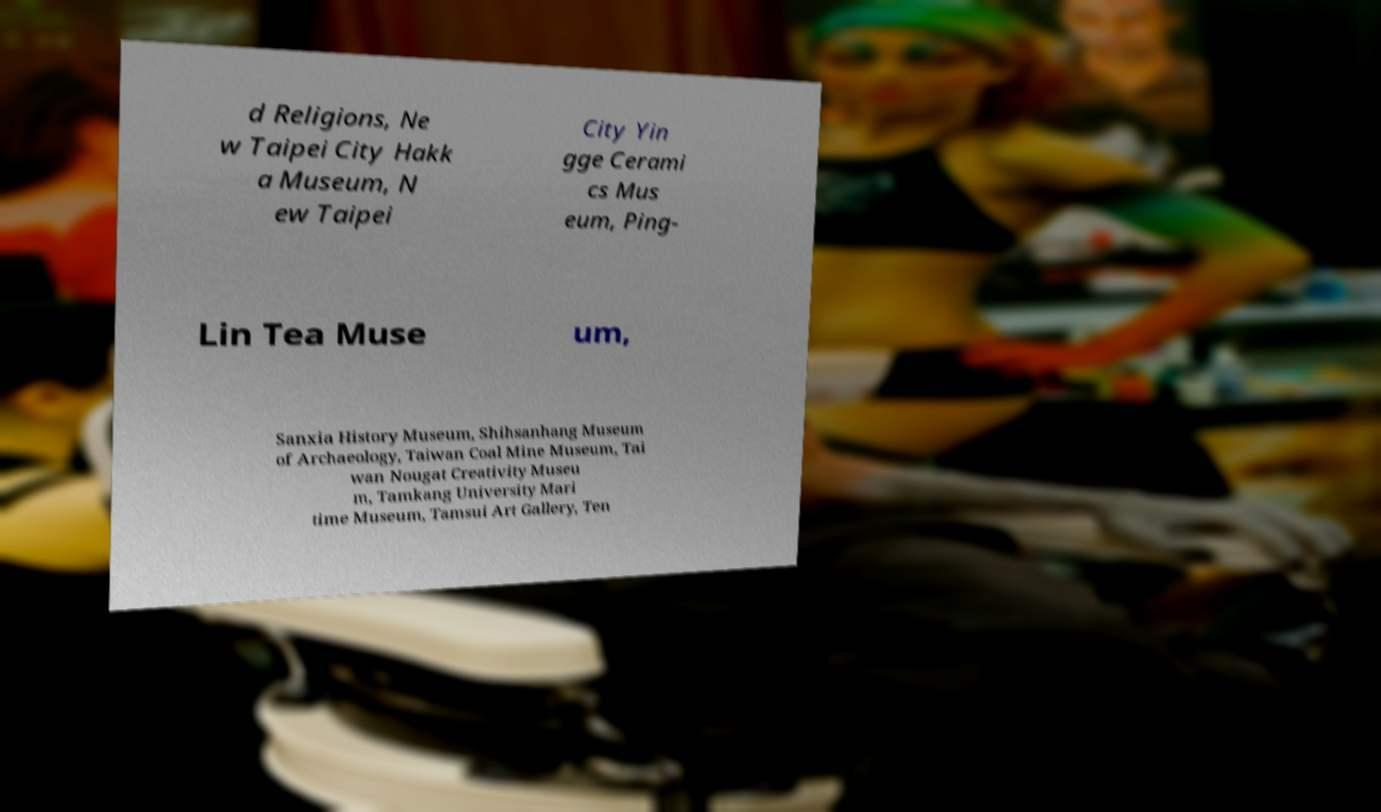For documentation purposes, I need the text within this image transcribed. Could you provide that? d Religions, Ne w Taipei City Hakk a Museum, N ew Taipei City Yin gge Cerami cs Mus eum, Ping- Lin Tea Muse um, Sanxia History Museum, Shihsanhang Museum of Archaeology, Taiwan Coal Mine Museum, Tai wan Nougat Creativity Museu m, Tamkang University Mari time Museum, Tamsui Art Gallery, Ten 